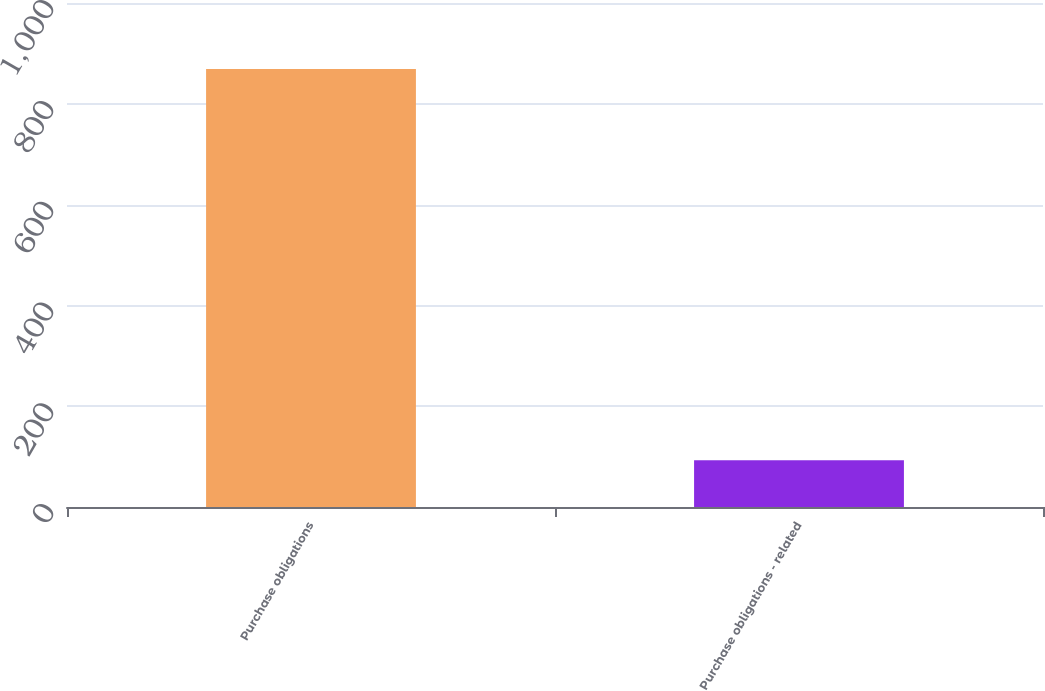<chart> <loc_0><loc_0><loc_500><loc_500><bar_chart><fcel>Purchase obligations<fcel>Purchase obligations - related<nl><fcel>869<fcel>93<nl></chart> 